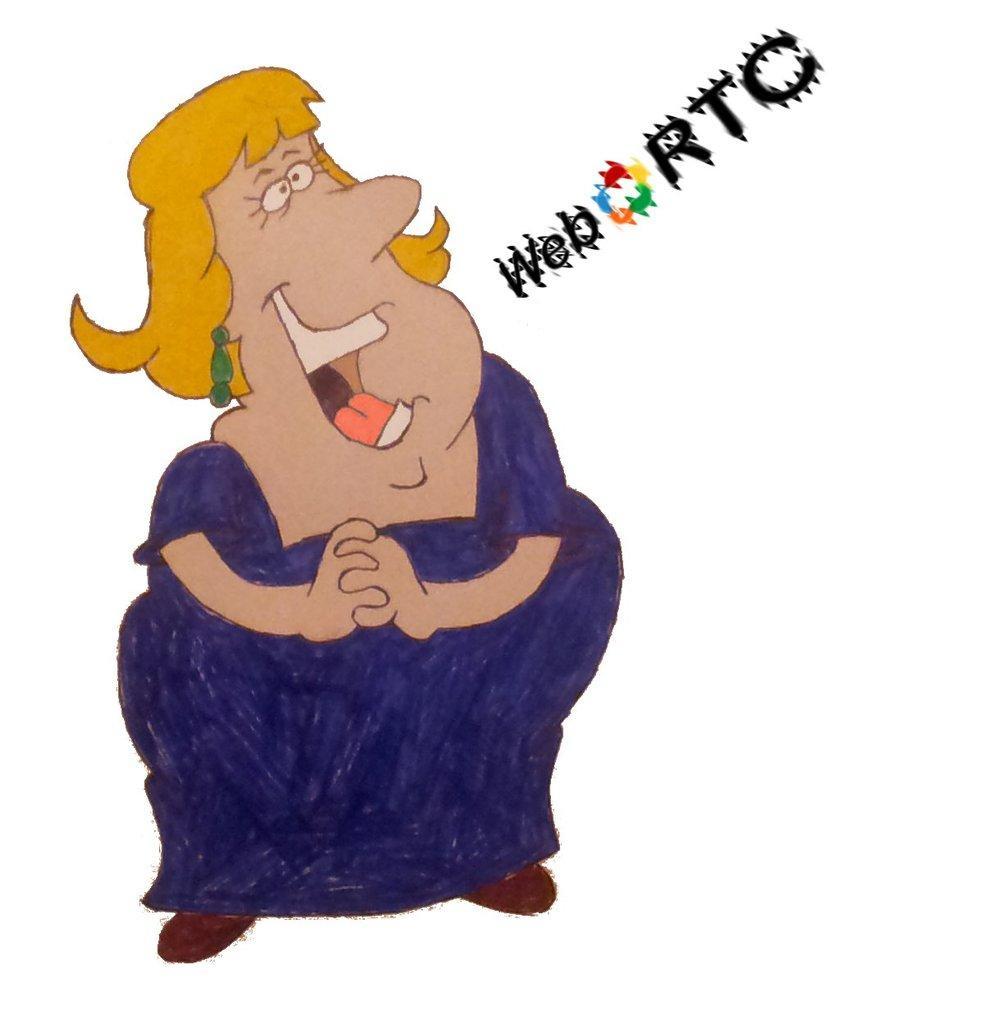Please provide a concise description of this image. In this picture I can see a cartoon character of a woman and I see something is written on the right side of this picture. I see that it is white color in the background. 